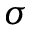<formula> <loc_0><loc_0><loc_500><loc_500>\sigma</formula> 